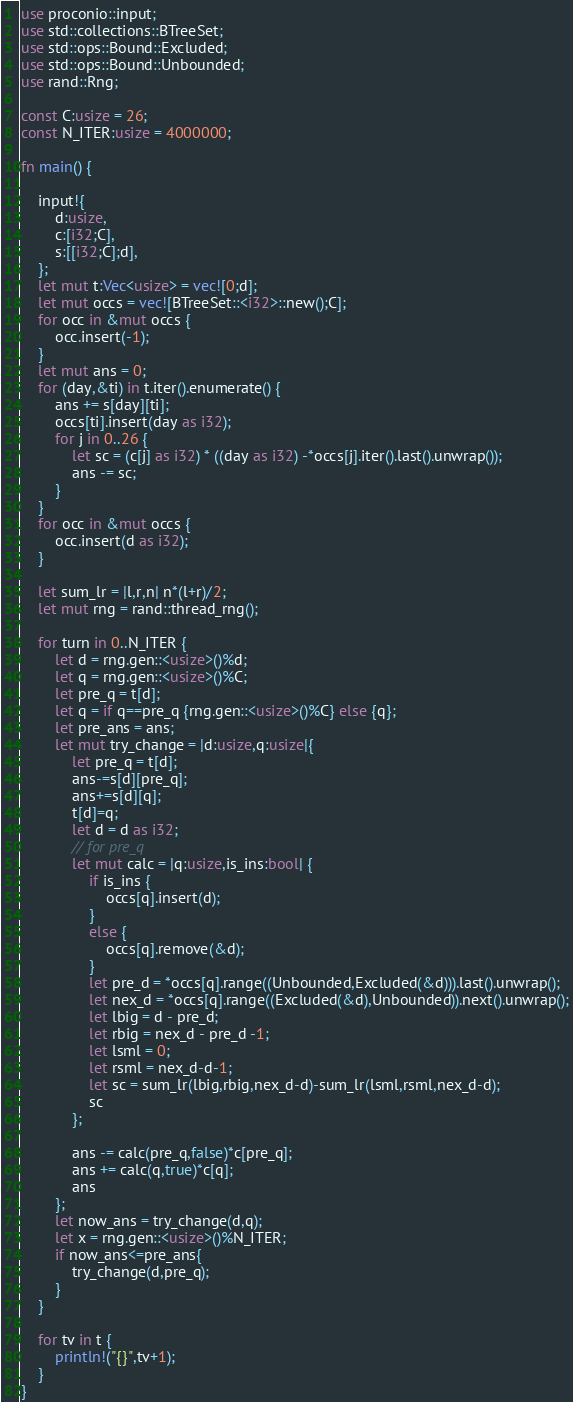Convert code to text. <code><loc_0><loc_0><loc_500><loc_500><_Rust_>use proconio::input;
use std::collections::BTreeSet;
use std::ops::Bound::Excluded;
use std::ops::Bound::Unbounded;
use rand::Rng;

const C:usize = 26;
const N_ITER:usize = 4000000;

fn main() {

    input!{
        d:usize,
        c:[i32;C],
        s:[[i32;C];d],
    };
    let mut t:Vec<usize> = vec![0;d];
    let mut occs = vec![BTreeSet::<i32>::new();C];
    for occ in &mut occs {
        occ.insert(-1);
    }
    let mut ans = 0;
    for (day,&ti) in t.iter().enumerate() {
        ans += s[day][ti];
        occs[ti].insert(day as i32);
        for j in 0..26 {
            let sc = (c[j] as i32) * ((day as i32) -*occs[j].iter().last().unwrap());
            ans -= sc;
        }
    }
    for occ in &mut occs {
        occ.insert(d as i32);
    }    

    let sum_lr = |l,r,n| n*(l+r)/2;
    let mut rng = rand::thread_rng();
    
    for turn in 0..N_ITER {
        let d = rng.gen::<usize>()%d;
        let q = rng.gen::<usize>()%C;
        let pre_q = t[d];
        let q = if q==pre_q {rng.gen::<usize>()%C} else {q};
        let pre_ans = ans;
        let mut try_change = |d:usize,q:usize|{
            let pre_q = t[d];
            ans-=s[d][pre_q];
            ans+=s[d][q];
            t[d]=q;
            let d = d as i32;
            // for pre_q
            let mut calc = |q:usize,is_ins:bool| {
                if is_ins {
                    occs[q].insert(d);
                }
                else {
                    occs[q].remove(&d);
                }
                let pre_d = *occs[q].range((Unbounded,Excluded(&d))).last().unwrap();
                let nex_d = *occs[q].range((Excluded(&d),Unbounded)).next().unwrap();
                let lbig = d - pre_d;
                let rbig = nex_d - pre_d -1;
                let lsml = 0;
                let rsml = nex_d-d-1;
                let sc = sum_lr(lbig,rbig,nex_d-d)-sum_lr(lsml,rsml,nex_d-d);
                sc
            };
            
            ans -= calc(pre_q,false)*c[pre_q];
            ans += calc(q,true)*c[q];
            ans
        };
        let now_ans = try_change(d,q);
        let x = rng.gen::<usize>()%N_ITER;
        if now_ans<=pre_ans{
            try_change(d,pre_q);
        }
    }

    for tv in t {
        println!("{}",tv+1);
    }
}


</code> 